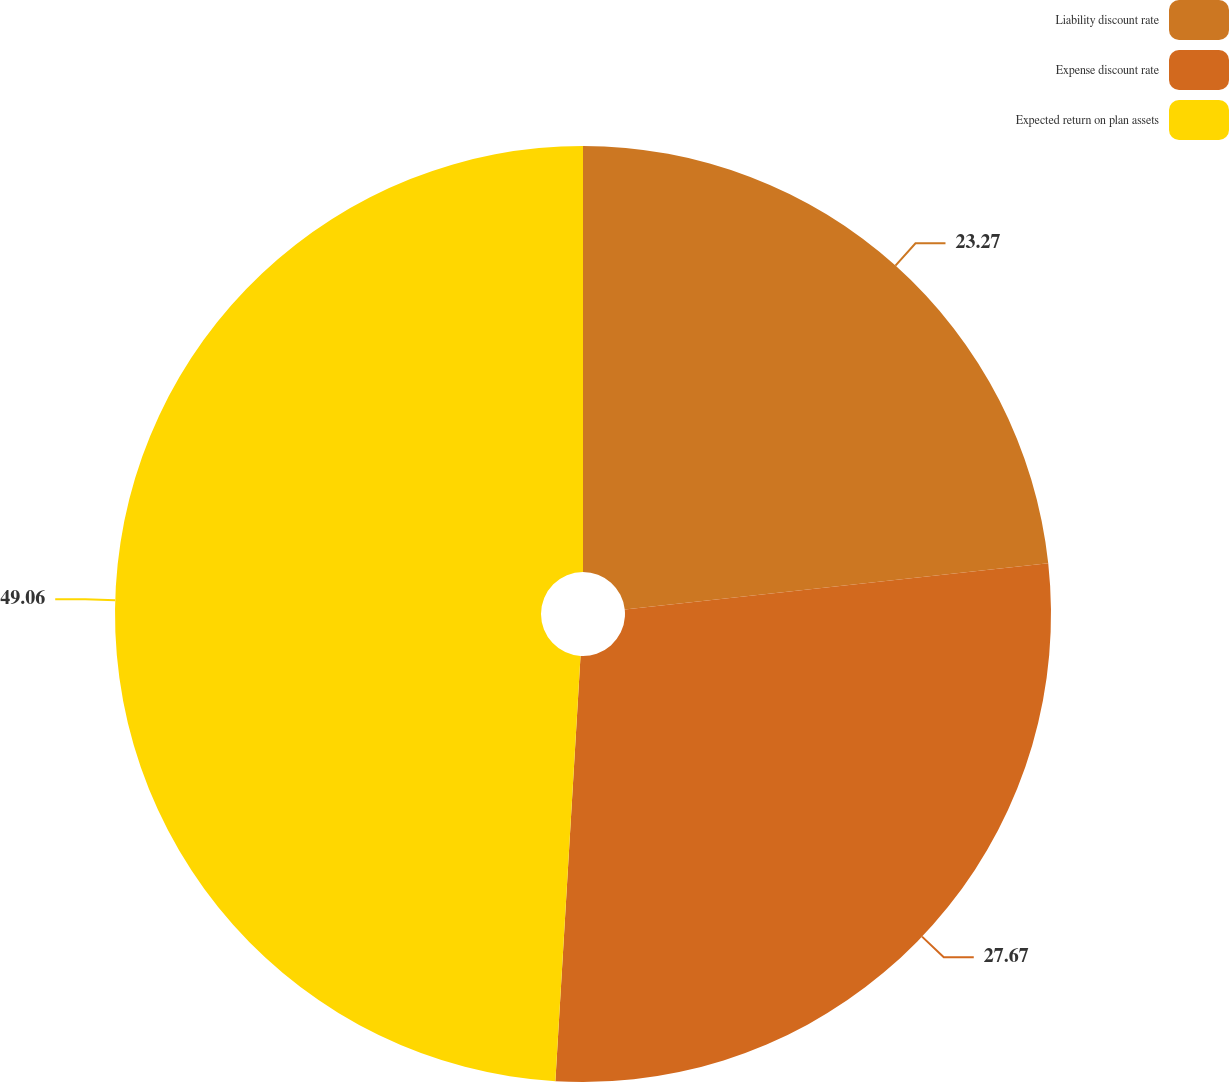Convert chart. <chart><loc_0><loc_0><loc_500><loc_500><pie_chart><fcel>Liability discount rate<fcel>Expense discount rate<fcel>Expected return on plan assets<nl><fcel>23.27%<fcel>27.67%<fcel>49.06%<nl></chart> 